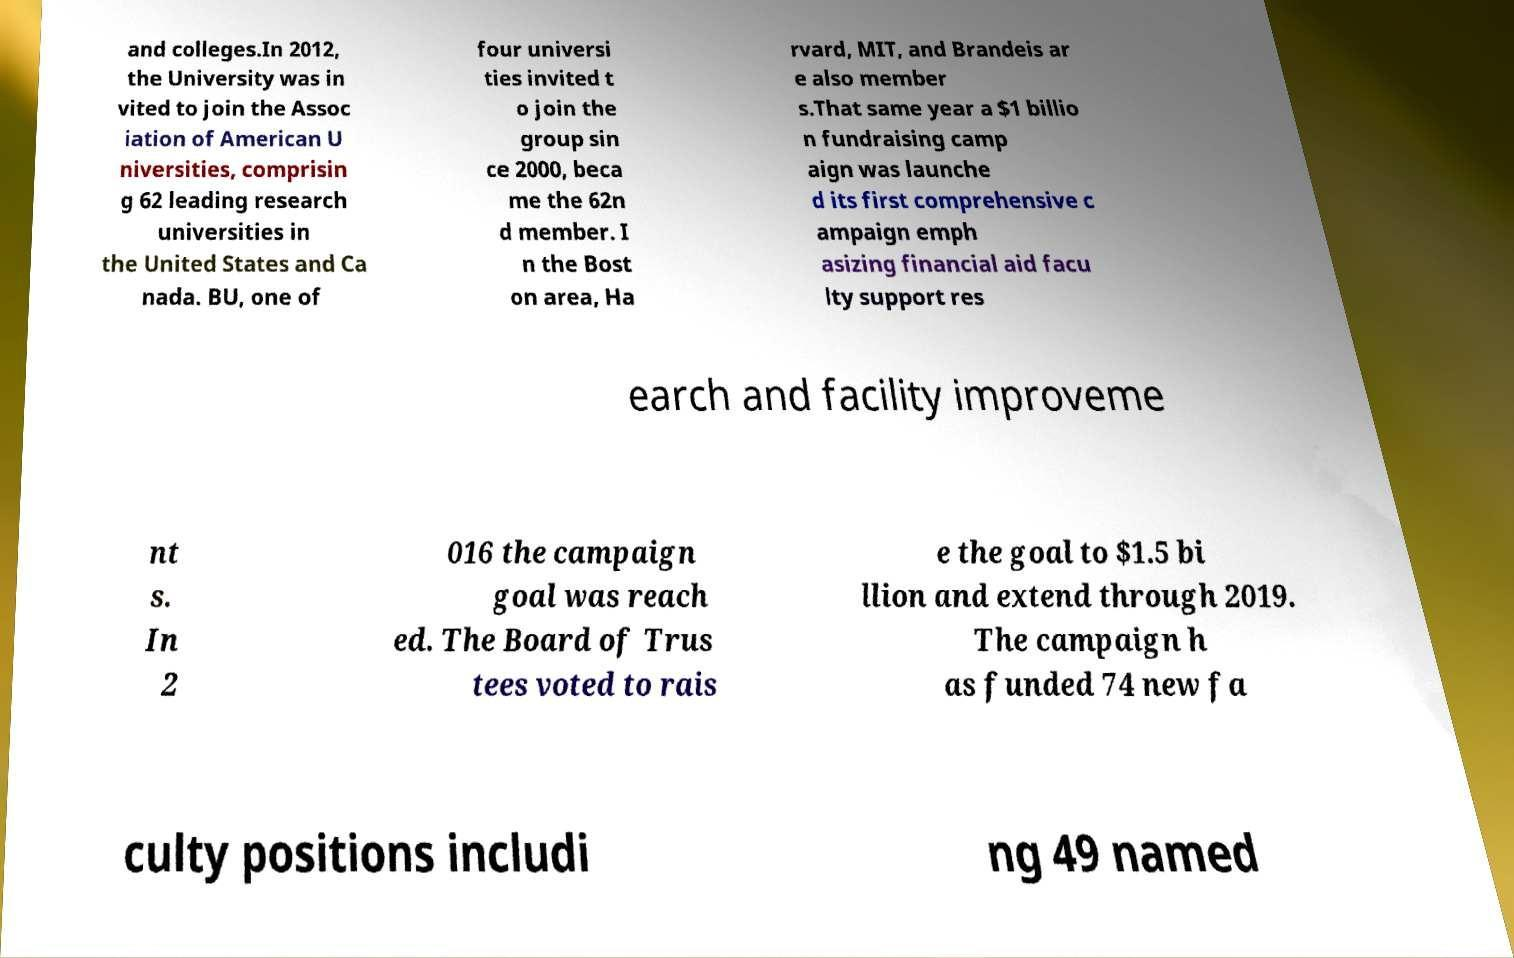Can you read and provide the text displayed in the image?This photo seems to have some interesting text. Can you extract and type it out for me? and colleges.In 2012, the University was in vited to join the Assoc iation of American U niversities, comprisin g 62 leading research universities in the United States and Ca nada. BU, one of four universi ties invited t o join the group sin ce 2000, beca me the 62n d member. I n the Bost on area, Ha rvard, MIT, and Brandeis ar e also member s.That same year a $1 billio n fundraising camp aign was launche d its first comprehensive c ampaign emph asizing financial aid facu lty support res earch and facility improveme nt s. In 2 016 the campaign goal was reach ed. The Board of Trus tees voted to rais e the goal to $1.5 bi llion and extend through 2019. The campaign h as funded 74 new fa culty positions includi ng 49 named 